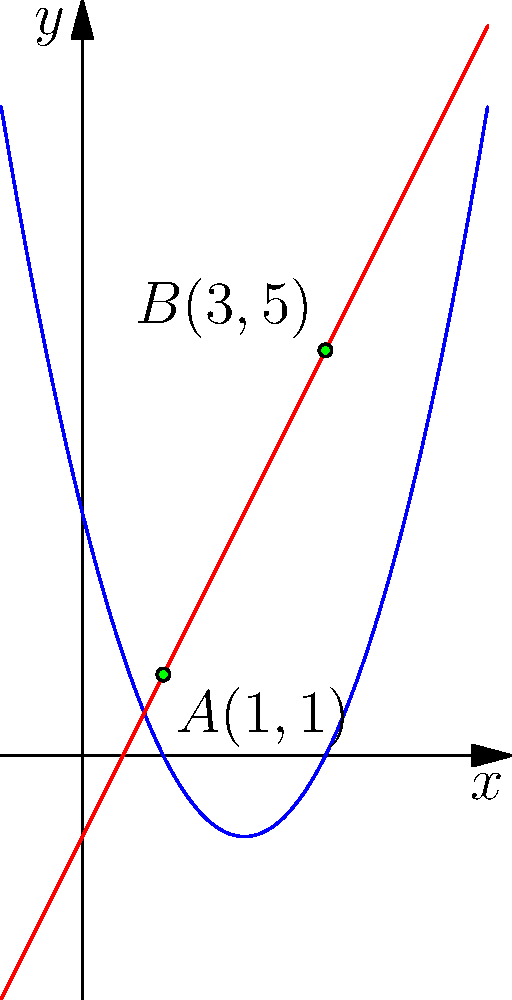In the golden age of cinema, directors often used visual metaphors to convey complex ideas. Imagine a scene where the path of a classic film's protagonist is represented by a parabola, while the antagonist's journey is depicted by a straight line. The parabola is given by the equation $y = x^2 - 4x + 3$, and the straight line by $y = 2x - 1$. At which points do these paths intersect, symbolizing the confrontations between the characters? Let's approach this step-by-step, as we would analyze the structure of a classic film:

1) To find the intersection points, we need to solve the equation:
   $x^2 - 4x + 3 = 2x - 1$

2) Rearranging the equation:
   $x^2 - 6x + 4 = 0$

3) This is a quadratic equation. We can solve it using the quadratic formula:
   $x = \frac{-b \pm \sqrt{b^2 - 4ac}}{2a}$

   Where $a=1$, $b=-6$, and $c=4$

4) Substituting these values:
   $x = \frac{6 \pm \sqrt{36 - 16}}{2} = \frac{6 \pm \sqrt{20}}{2} = \frac{6 \pm 2\sqrt{5}}{2}$

5) Simplifying:
   $x = 3 \pm \sqrt{5}$

6) Therefore, the x-coordinates of the intersection points are:
   $x_1 = 3 + \sqrt{5} \approx 5.236$
   $x_2 = 3 - \sqrt{5} \approx 0.764$

7) To find the y-coordinates, we can substitute these x-values into either of the original equations. Let's use the straight line equation:

   For $x_1$: $y_1 = 2(3 + \sqrt{5}) - 1 = 5 + 2\sqrt{5}$
   For $x_2$: $y_2 = 2(3 - \sqrt{5}) - 1 = 5 - 2\sqrt{5}$

8) Therefore, the intersection points are:
   $A(3 - \sqrt{5}, 5 - 2\sqrt{5})$ and $B(3 + \sqrt{5}, 5 + 2\sqrt{5})$

9) Simplifying to decimal approximations:
   $A(0.764, 0.528)$ and $B(5.236, 9.472)$

These points represent the moments of confrontation between our protagonist and antagonist in the metaphorical space of the film.
Answer: $A(3 - \sqrt{5}, 5 - 2\sqrt{5})$ and $B(3 + \sqrt{5}, 5 + 2\sqrt{5})$ 